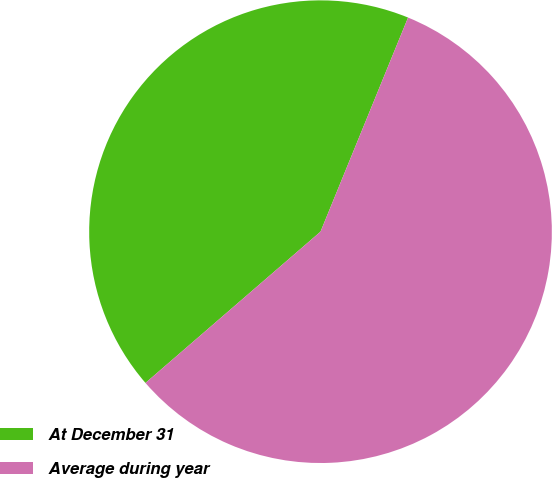<chart> <loc_0><loc_0><loc_500><loc_500><pie_chart><fcel>At December 31<fcel>Average during year<nl><fcel>42.52%<fcel>57.48%<nl></chart> 